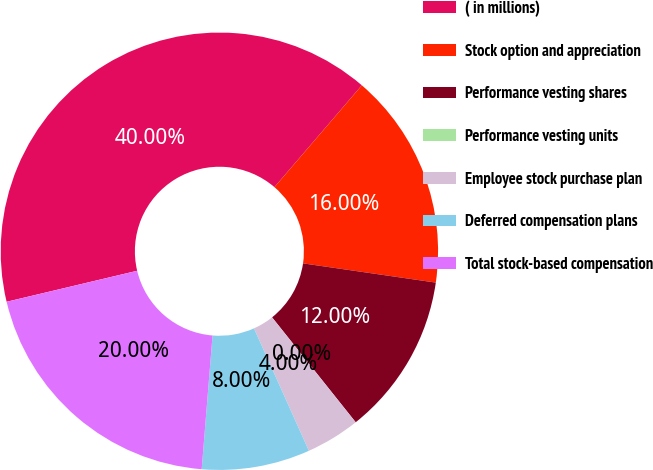<chart> <loc_0><loc_0><loc_500><loc_500><pie_chart><fcel>( in millions)<fcel>Stock option and appreciation<fcel>Performance vesting shares<fcel>Performance vesting units<fcel>Employee stock purchase plan<fcel>Deferred compensation plans<fcel>Total stock-based compensation<nl><fcel>40.0%<fcel>16.0%<fcel>12.0%<fcel>0.0%<fcel>4.0%<fcel>8.0%<fcel>20.0%<nl></chart> 